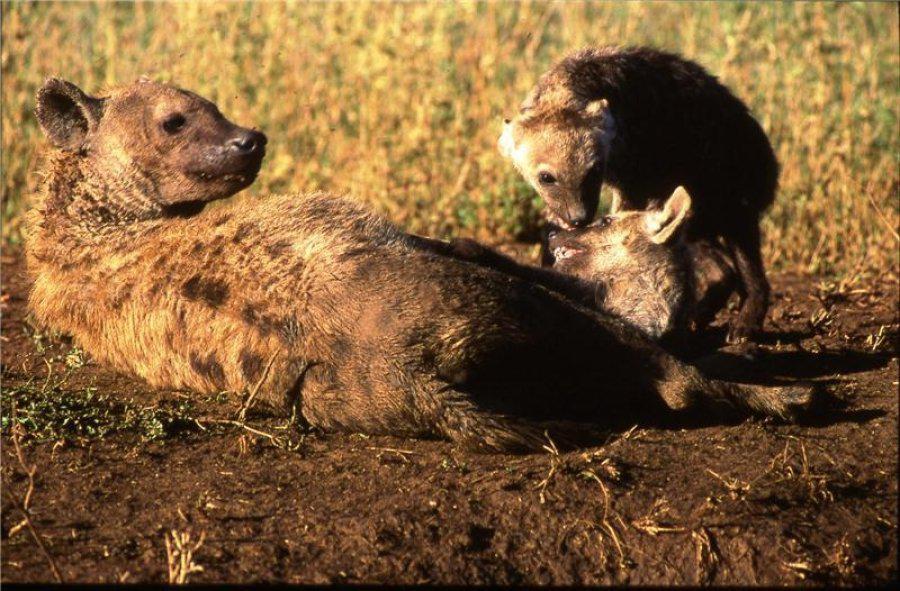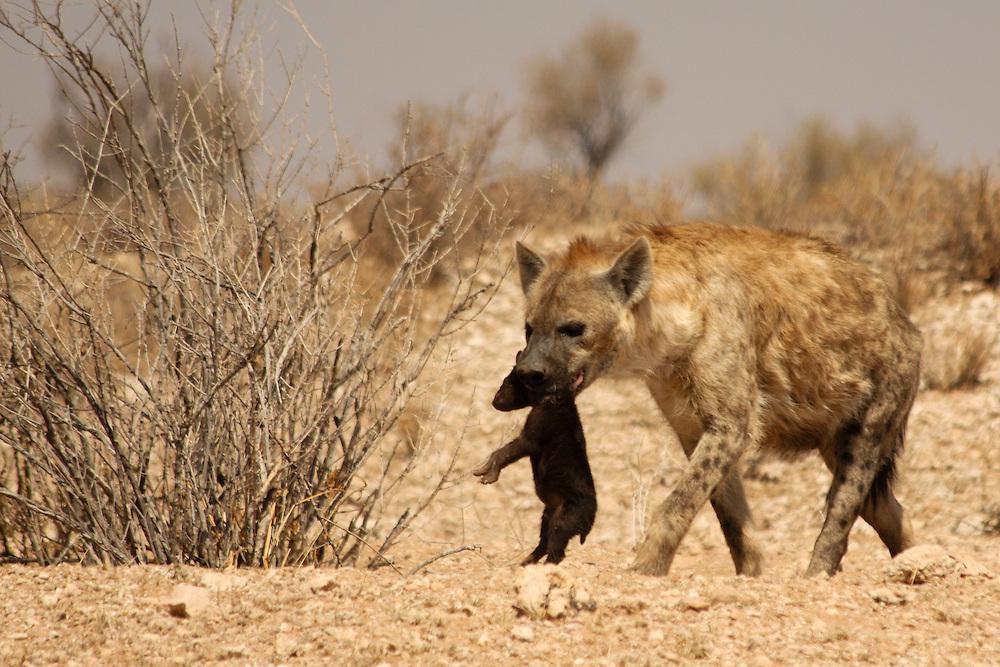The first image is the image on the left, the second image is the image on the right. For the images shown, is this caption "Each image shows one adult hyena carrying at least one pup in its mouth." true? Answer yes or no. No. 